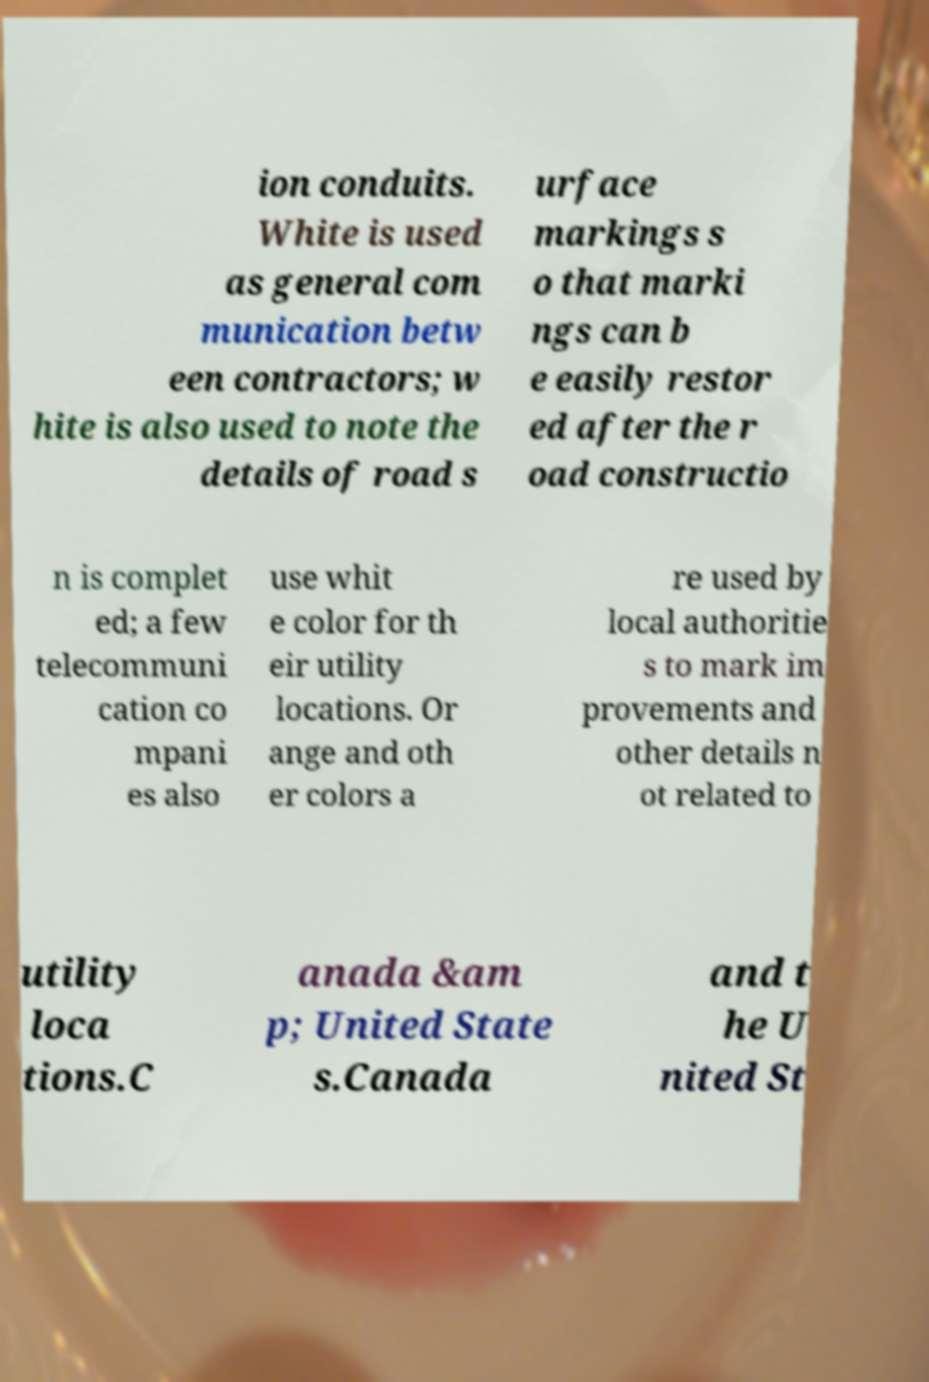I need the written content from this picture converted into text. Can you do that? ion conduits. White is used as general com munication betw een contractors; w hite is also used to note the details of road s urface markings s o that marki ngs can b e easily restor ed after the r oad constructio n is complet ed; a few telecommuni cation co mpani es also use whit e color for th eir utility locations. Or ange and oth er colors a re used by local authoritie s to mark im provements and other details n ot related to utility loca tions.C anada &am p; United State s.Canada and t he U nited St 